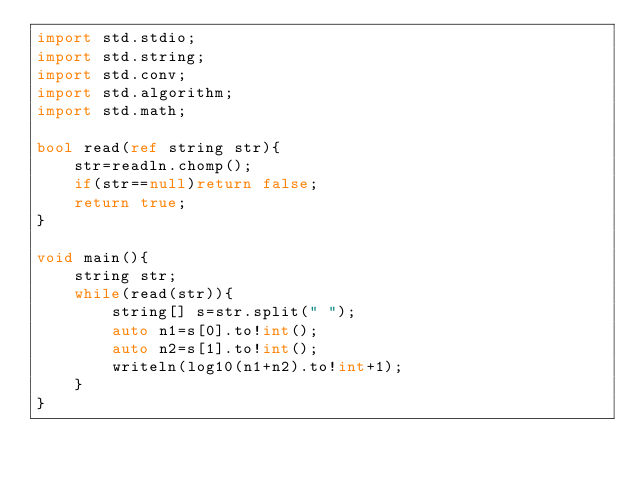<code> <loc_0><loc_0><loc_500><loc_500><_D_>import std.stdio;
import std.string;
import std.conv;
import std.algorithm;
import std.math;

bool read(ref string str){
	str=readln.chomp();
	if(str==null)return false;
	return true;
}

void main(){
	string str;
	while(read(str)){
		string[] s=str.split(" ");
		auto n1=s[0].to!int();
		auto n2=s[1].to!int();
		writeln(log10(n1+n2).to!int+1);
	}
}</code> 